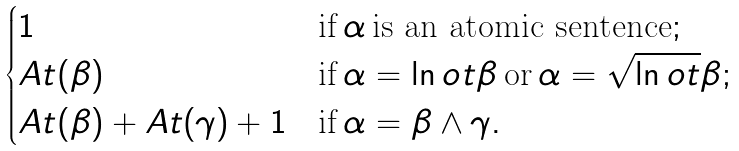Convert formula to latex. <formula><loc_0><loc_0><loc_500><loc_500>\begin{cases} 1 & \text {if} \, \alpha \, \text {is an atomic sentence} ; \\ A t ( \beta ) & \text {if} \, \alpha = \ln o t \beta \, \text {or} \, \alpha = \sqrt { \ln o t } \beta ; \\ A t ( \beta ) + A t ( \gamma ) + 1 & \text {if} \, \alpha = \beta \land \gamma . \end{cases}</formula> 